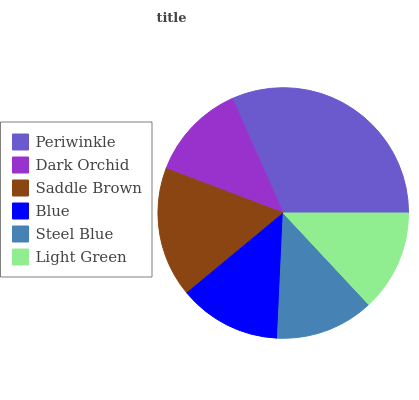Is Dark Orchid the minimum?
Answer yes or no. Yes. Is Periwinkle the maximum?
Answer yes or no. Yes. Is Saddle Brown the minimum?
Answer yes or no. No. Is Saddle Brown the maximum?
Answer yes or no. No. Is Saddle Brown greater than Dark Orchid?
Answer yes or no. Yes. Is Dark Orchid less than Saddle Brown?
Answer yes or no. Yes. Is Dark Orchid greater than Saddle Brown?
Answer yes or no. No. Is Saddle Brown less than Dark Orchid?
Answer yes or no. No. Is Blue the high median?
Answer yes or no. Yes. Is Light Green the low median?
Answer yes or no. Yes. Is Light Green the high median?
Answer yes or no. No. Is Dark Orchid the low median?
Answer yes or no. No. 